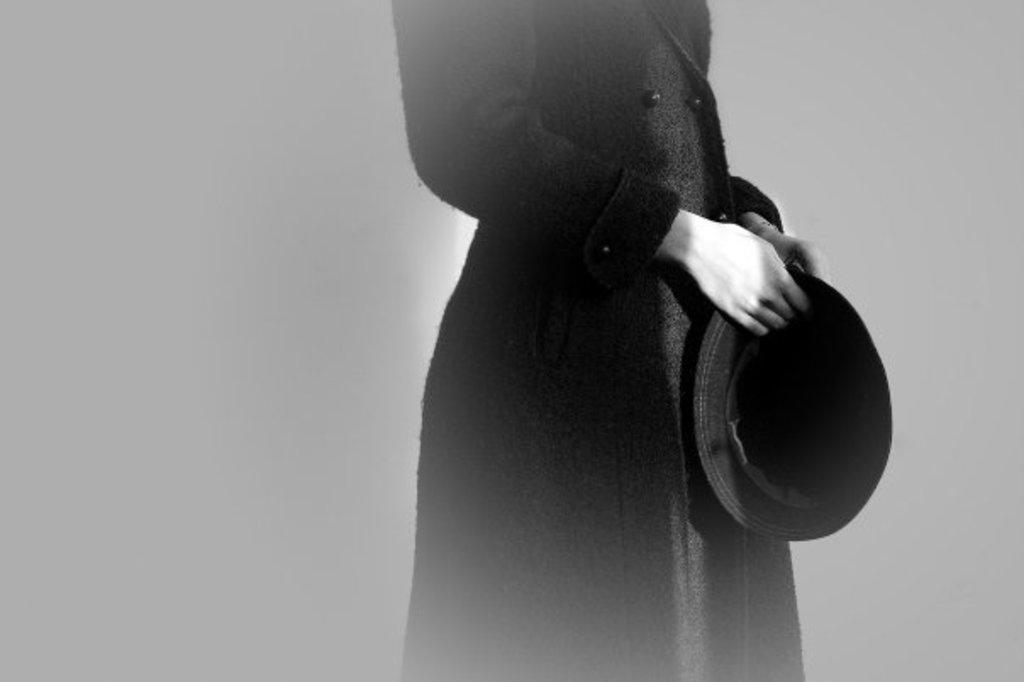What is the main subject of the image? There is a person standing in the image. What is the person wearing? The person is wearing a black coat. What object is the person holding? The person is holding a hat in their hands. What color scheme is used in the image? The image is black and white. What type of tax is being discussed in the image? There is no discussion of tax in the image; it features a person standing, wearing a black coat, and holding a hat. What kind of lunch is being served in the image? There is no lunch present in the image; it only shows a person standing, wearing a black coat, and holding a hat. 